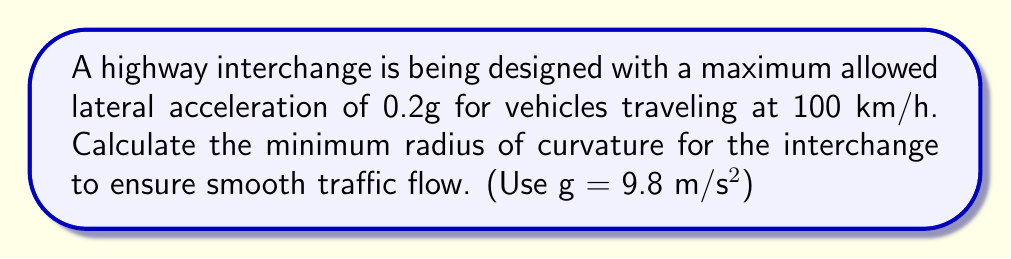Could you help me with this problem? To find the radius of curvature, we'll use the formula for centripetal acceleration:

$$a_c = \frac{v^2}{r}$$

Where:
$a_c$ = centripetal acceleration
$v$ = velocity
$r$ = radius of curvature

Step 1: Convert the given speed to m/s
$$100 \text{ km/h} = \frac{100 \times 1000}{3600} \text{ m/s} = 27.78 \text{ m/s}$$

Step 2: Calculate the centripetal acceleration
$$a_c = 0.2g = 0.2 \times 9.8 \text{ m/s}^2 = 1.96 \text{ m/s}^2$$

Step 3: Substitute the values into the centripetal acceleration formula
$$1.96 = \frac{27.78^2}{r}$$

Step 4: Solve for r
$$r = \frac{27.78^2}{1.96} = 393.44 \text{ m}$$

Therefore, the minimum radius of curvature for the interchange should be approximately 393.44 meters.
Answer: $393.44 \text{ m}$ 